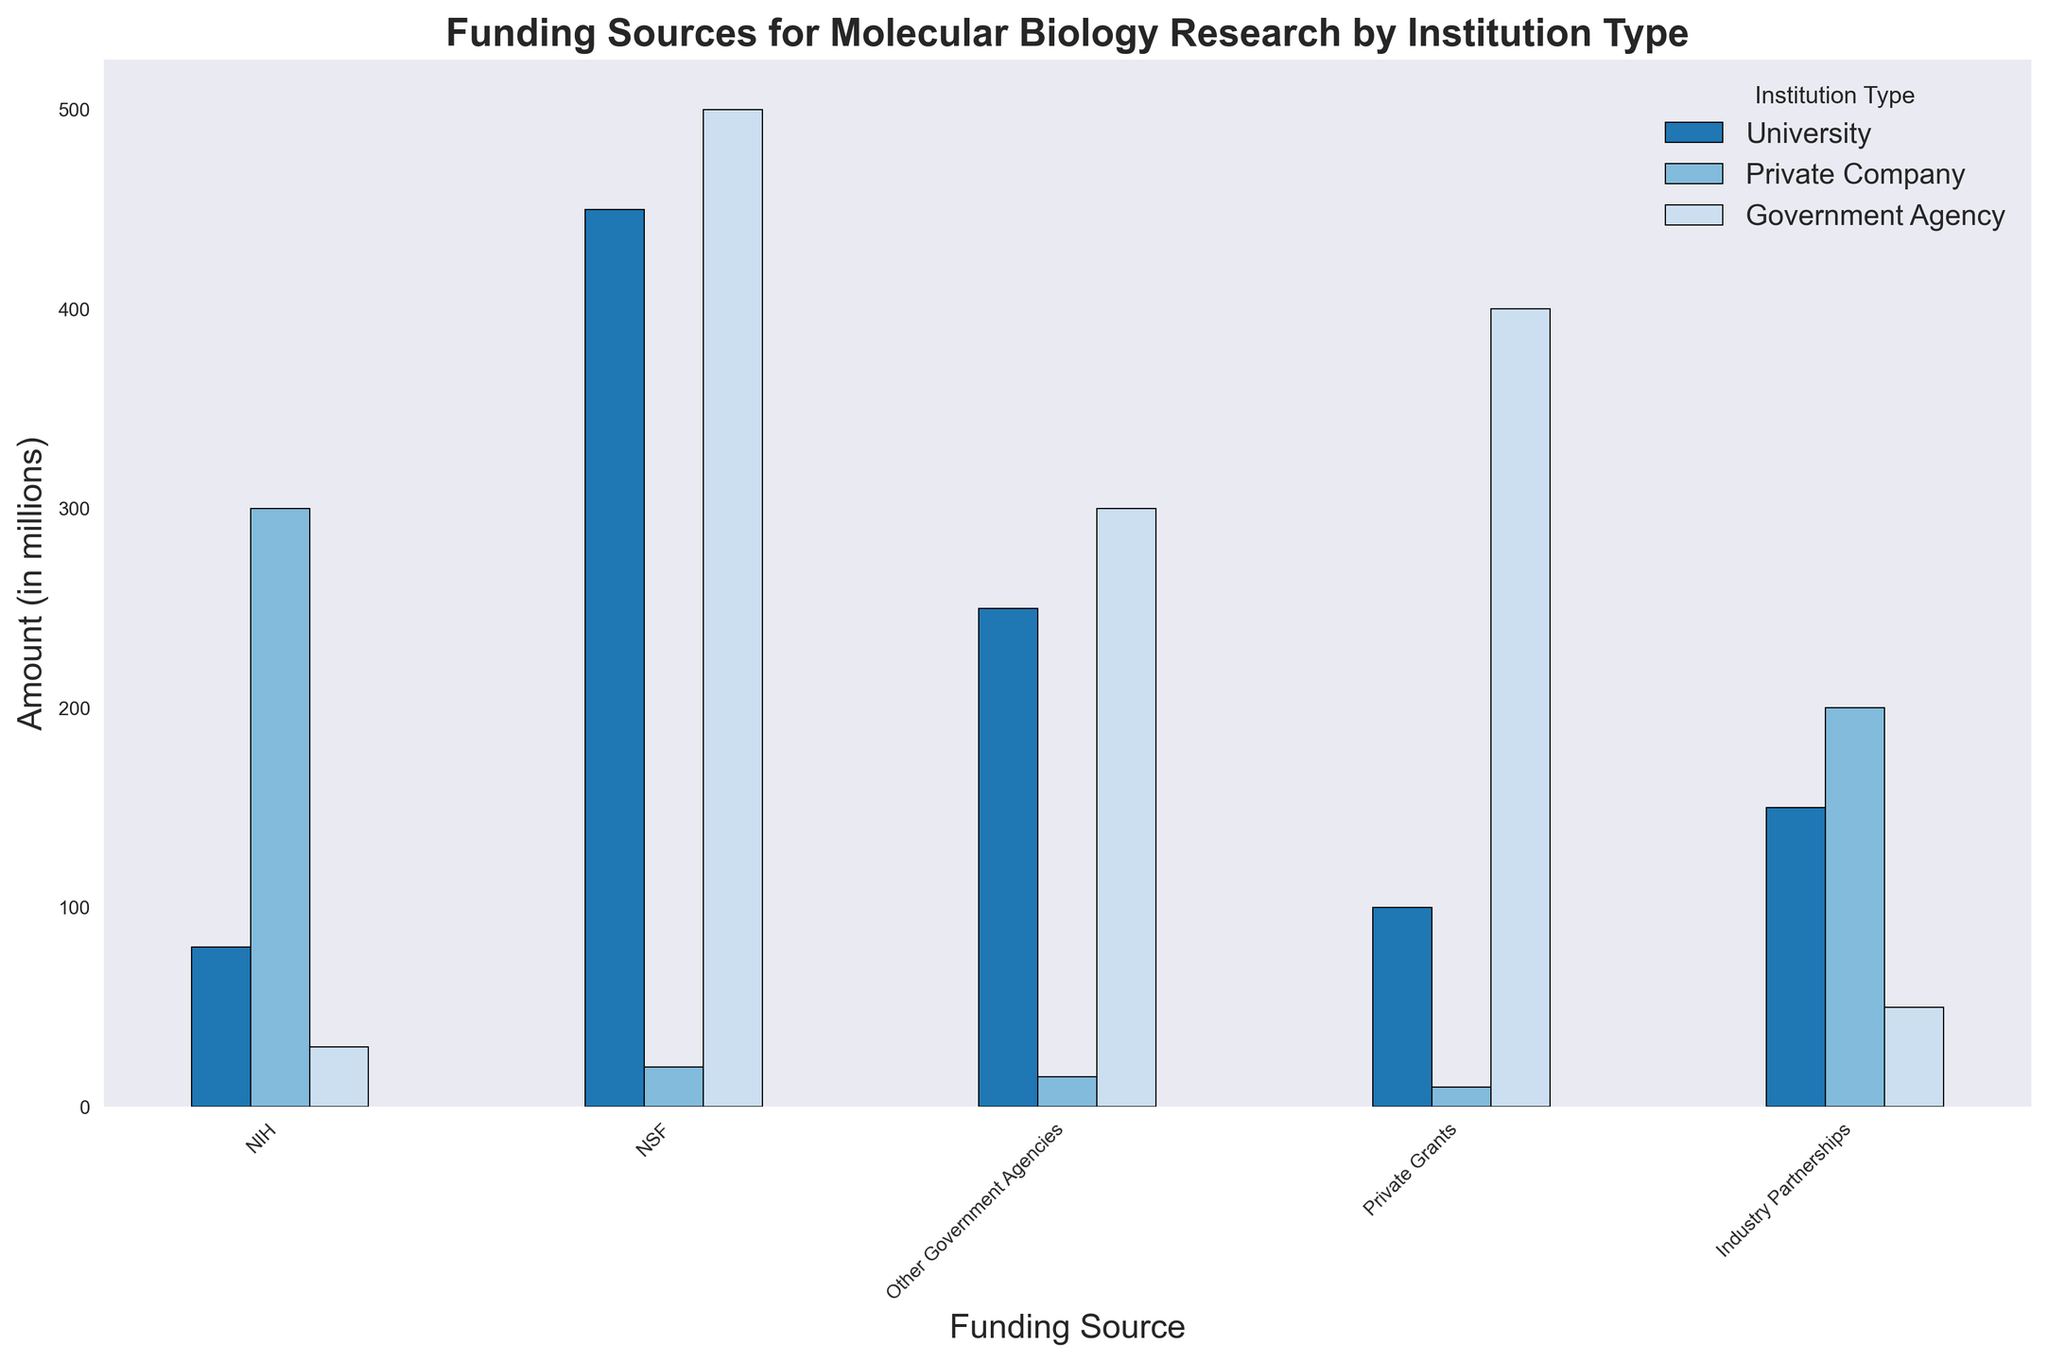What's the total funding amount from NIH for all institution types? To find the total NIH funding, sum up the NIH-related amounts from each institution type. The values are NIH (University) = 450, NIH (Private Company) = 20, and NIH (Government Agency) = 500. Therefore, the total is 450 + 20 + 500 = 970.
Answer: 970 Which institution type receives the highest amount of funding from Industry Partnerships? By comparing the Industry Partnerships funding for each institution type: University = 80, Private Company = 300, and Government Agency = 30, the highest amount is for Private Company with 300 million.
Answer: Private Company What is the average funding amount from NSF across all institution types? To find the average NSF funding amount, sum the NSF amounts for all institutions and divide by the number of institution types. The values are NSF (University) = 250, NSF (Private Company) = 15, and NSF (Government Agency) = 300. Sum these to get 250 + 15 + 300 = 565 and divide by 3, giving 565 / 3 ≈ 188.3.
Answer: 188.3 Which funding source contributes the least amount to Private Companies? By examining each funding source for Private Companies: NIH = 20, NSF = 15, Other Government Agencies = 10, Private Grants = 200, Industry Partnerships = 300. The least amount is from Other Government Agencies with 10 million.
Answer: Other Government Agencies What is the difference in funding from Private Grants between Universities and Private Companies? The funding from Private Grants for Universities is 150 and for Private Companies is 200. The difference is 200 - 150 = 50.
Answer: 50 Which institution type has the highest total funding across all sources? Calculate the total funding for each institution by summing their funds from all sources. For Universities: 450 + 250 + 100 + 150 + 80 = 1030. For Private Companies: 20 + 15 + 10 + 200 + 300 = 545. For Government Agencies: 500 + 300 + 400 + 50 + 30 = 1280. The highest total amount is for Government Agencies with 1280 million.
Answer: Government Agencies Which funding source has the most similar amount of funding between Universities and Government Agencies? Compare the amounts for each funding source between Universities and Government Agencies: NIH (450 vs 500), NSF (250 vs 300), Other Government Agencies (100 vs 400), Private Grants (150 vs 50), Industry Partnerships (80 vs 30). The closest values are for NIH, with a difference of 50 (500 - 450).
Answer: NIH What is the combined funding amount from Industry Partnerships and Other Government Agencies for Government Agencies? To find the combined amount, sum the values from Industry Partnerships and Other Government Agencies for Government Agencies. These are 30 and 400, respectively. So, the total is 30 + 400 = 430.
Answer: 430 